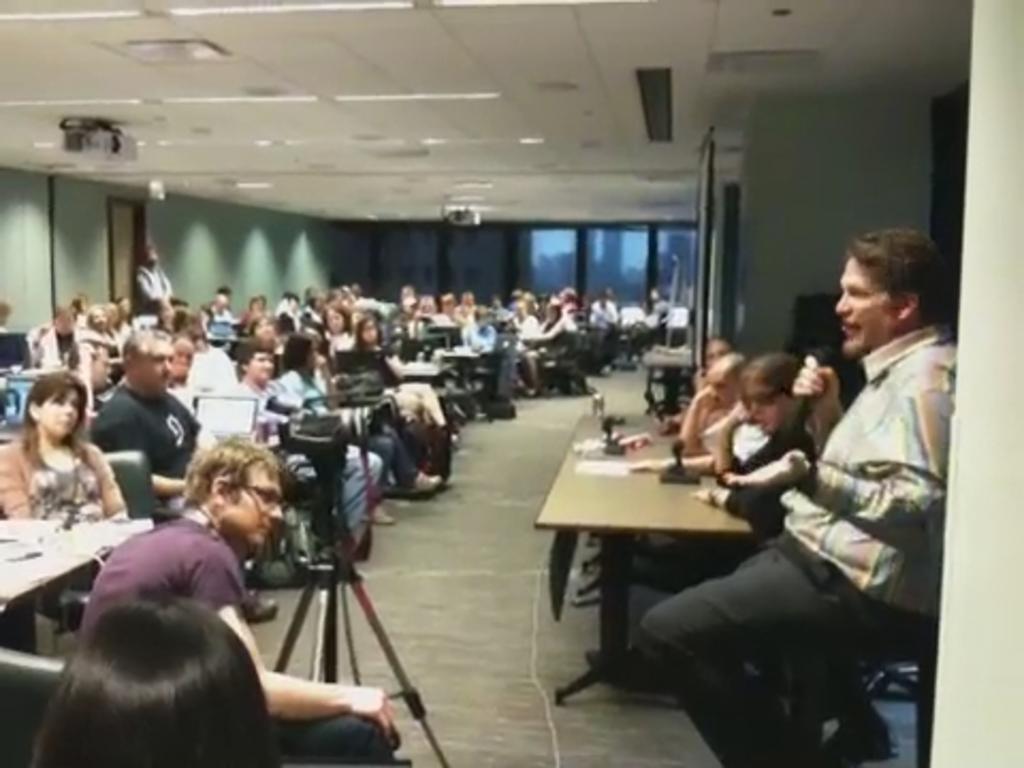Could you give a brief overview of what you see in this image? This picture is clicked in the conference room. The man on the right side is sitting on the chair. Beside him, we see three people sitting on the chairs. In front of them, we see many people sitting on the chairs. The man in purple T-shirt is sitting on the chair. In front of him, we see a camera stand. In the background, we see a green wall and a window. At the top of the picture, we see the ceiling of the room. 